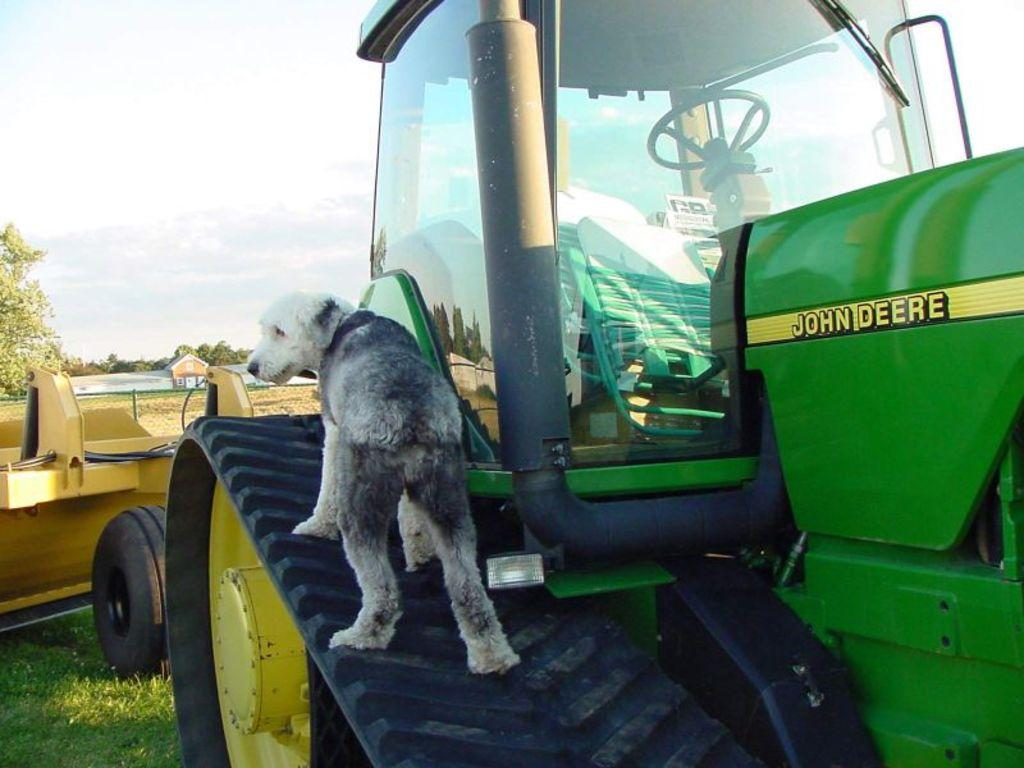What is the main subject in the foreground of the image? There is a vehicle in the foreground of the image. What is the dog doing in relation to the vehicle? A dog is standing on the wheel of the vehicle. What can be seen in the background of the image? There is a house, open land, and trees present in the background of the image. How many legs does the hen have in the image? There is no hen present in the image. What type of animal is interacting with the vehicle in the image? The only animal present in the image is a dog, which is standing on the wheel of the vehicle. 